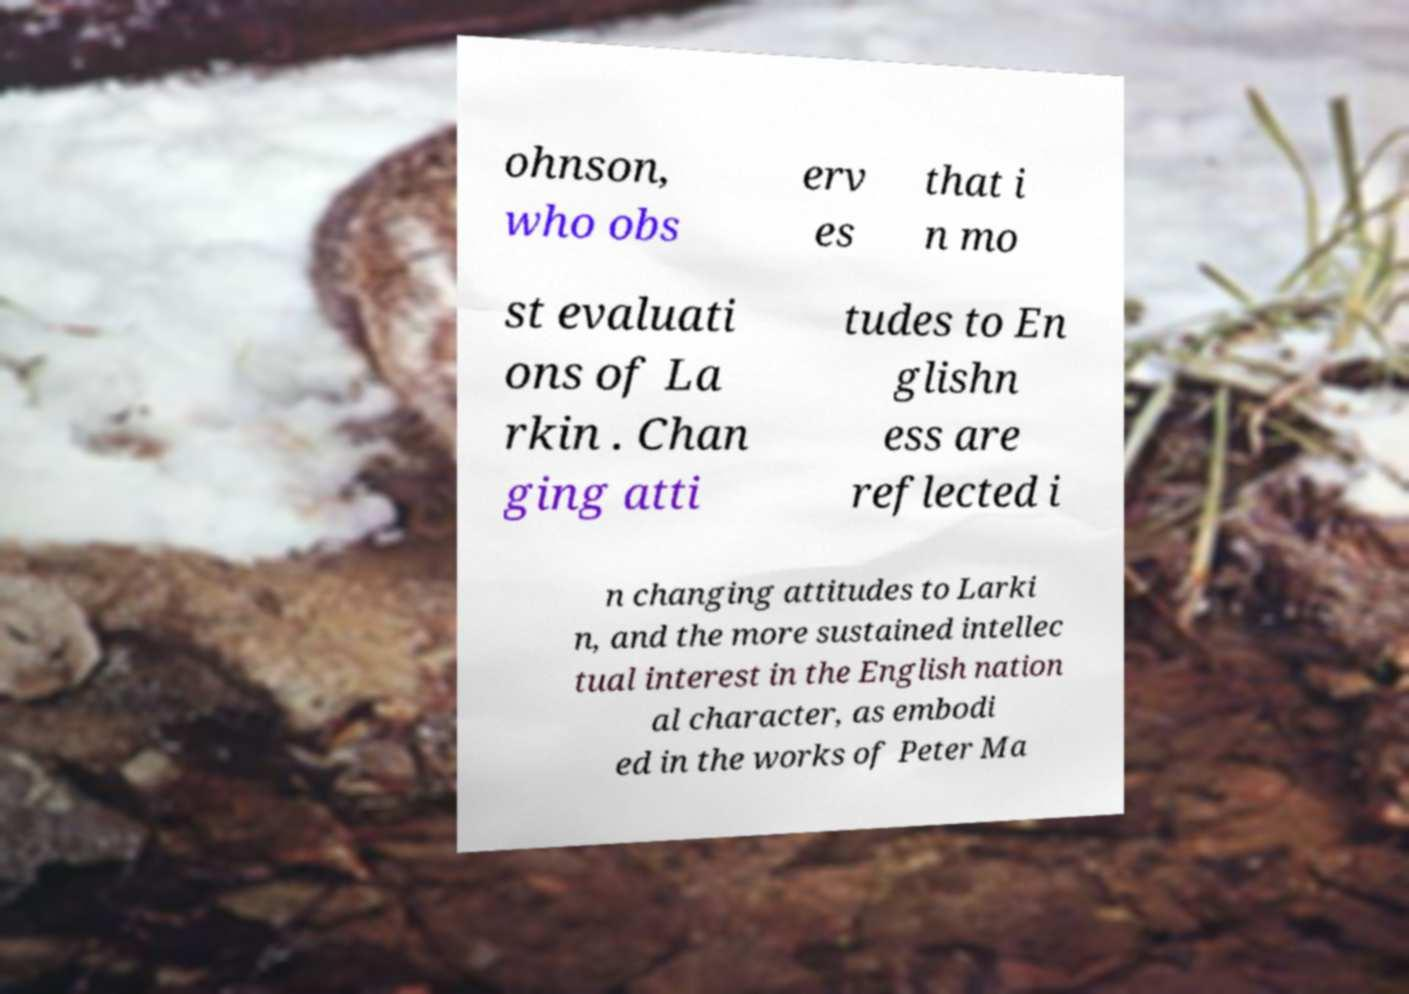Please read and relay the text visible in this image. What does it say? ohnson, who obs erv es that i n mo st evaluati ons of La rkin . Chan ging atti tudes to En glishn ess are reflected i n changing attitudes to Larki n, and the more sustained intellec tual interest in the English nation al character, as embodi ed in the works of Peter Ma 